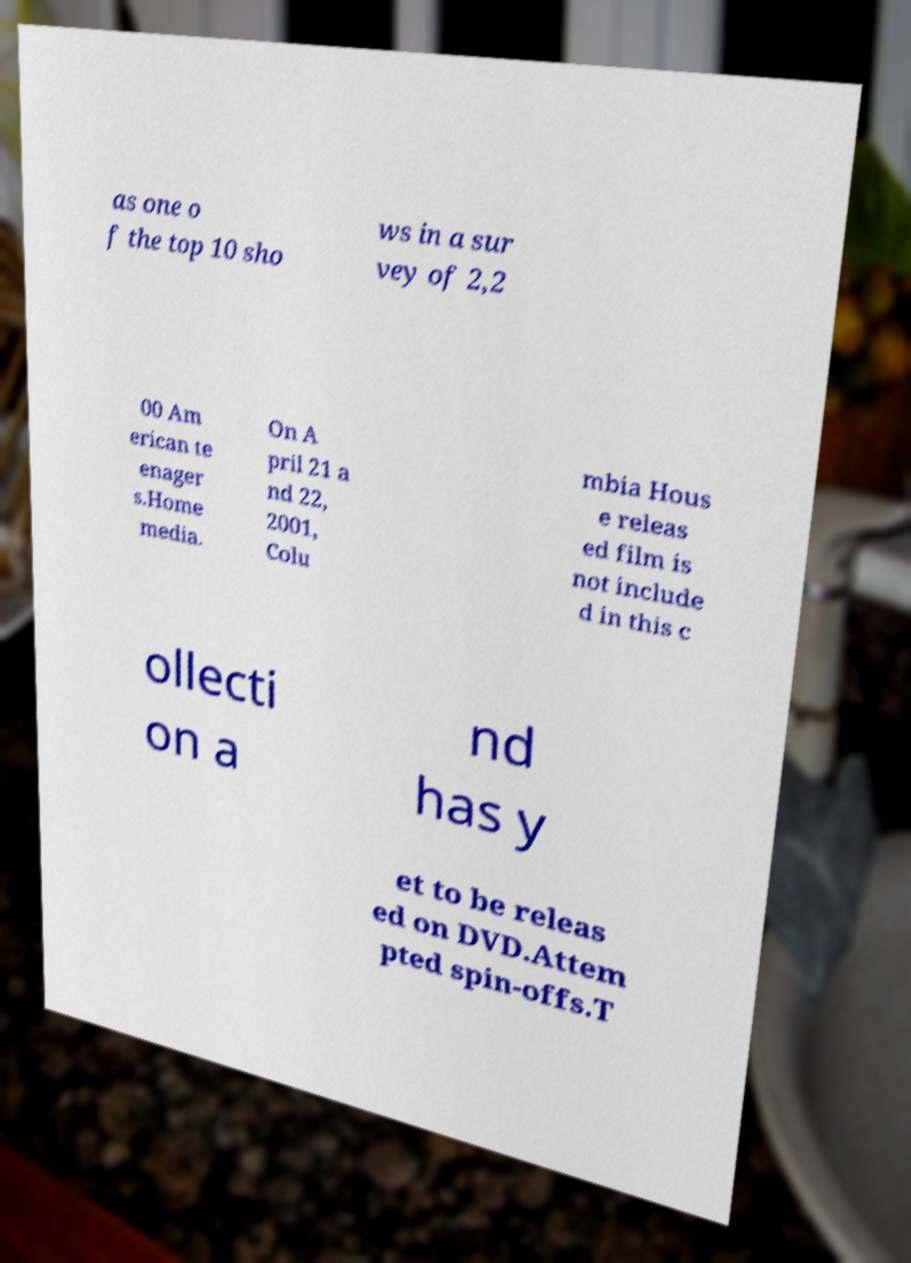Can you read and provide the text displayed in the image?This photo seems to have some interesting text. Can you extract and type it out for me? as one o f the top 10 sho ws in a sur vey of 2,2 00 Am erican te enager s.Home media. On A pril 21 a nd 22, 2001, Colu mbia Hous e releas ed film is not include d in this c ollecti on a nd has y et to be releas ed on DVD.Attem pted spin-offs.T 